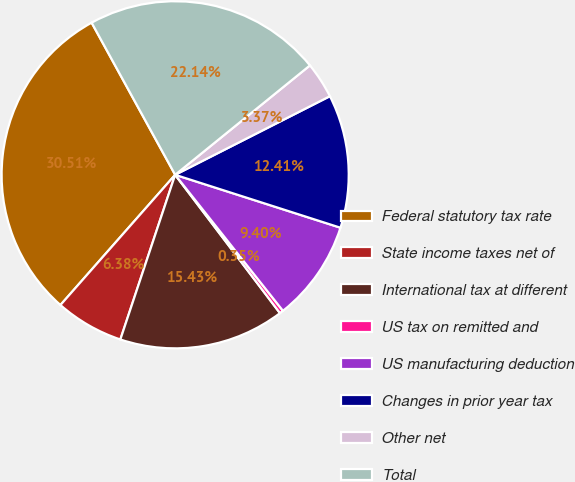Convert chart to OTSL. <chart><loc_0><loc_0><loc_500><loc_500><pie_chart><fcel>Federal statutory tax rate<fcel>State income taxes net of<fcel>International tax at different<fcel>US tax on remitted and<fcel>US manufacturing deduction<fcel>Changes in prior year tax<fcel>Other net<fcel>Total<nl><fcel>30.51%<fcel>6.38%<fcel>15.43%<fcel>0.35%<fcel>9.4%<fcel>12.41%<fcel>3.37%<fcel>22.14%<nl></chart> 